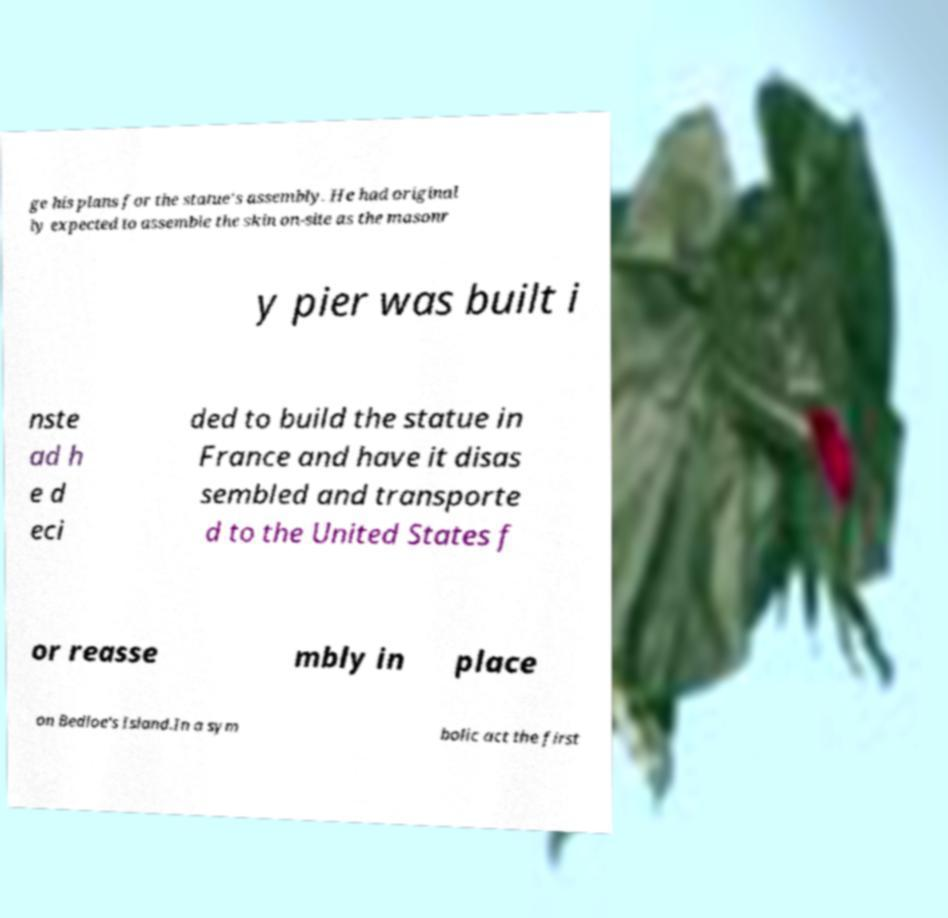Could you extract and type out the text from this image? ge his plans for the statue's assembly. He had original ly expected to assemble the skin on-site as the masonr y pier was built i nste ad h e d eci ded to build the statue in France and have it disas sembled and transporte d to the United States f or reasse mbly in place on Bedloe's Island.In a sym bolic act the first 